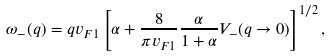Convert formula to latex. <formula><loc_0><loc_0><loc_500><loc_500>\omega _ { - } ( q ) = q v _ { F 1 } \left [ \alpha + \frac { 8 } { \pi v _ { F 1 } } \frac { \alpha } { 1 + \alpha } V _ { - } ( q \rightarrow 0 ) \right ] ^ { 1 / 2 } ,</formula> 